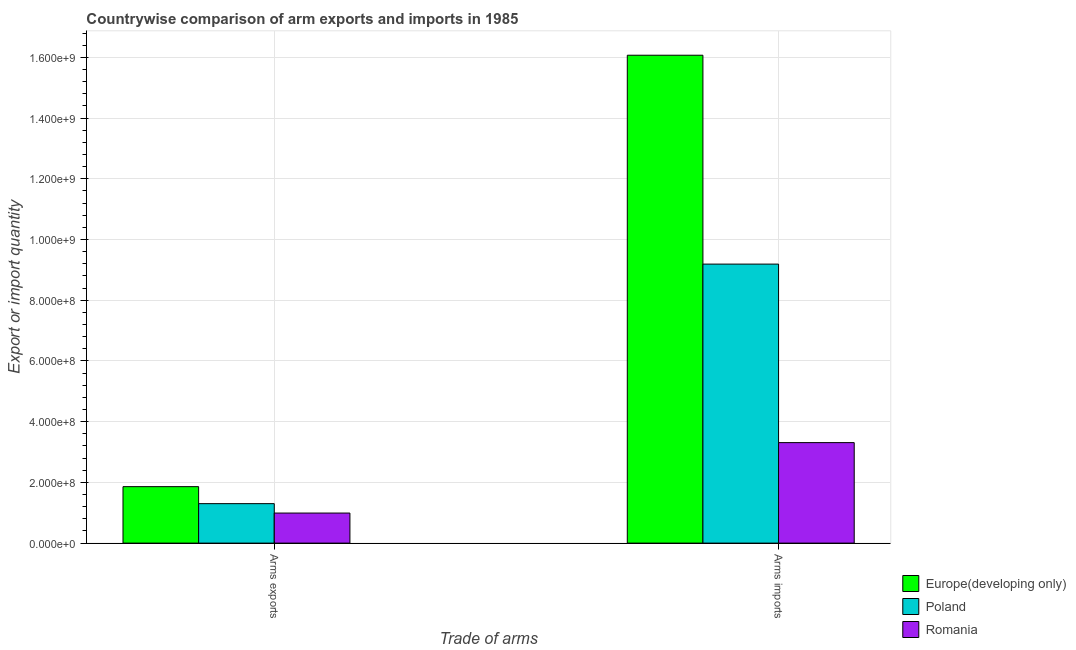How many groups of bars are there?
Ensure brevity in your answer.  2. Are the number of bars on each tick of the X-axis equal?
Give a very brief answer. Yes. How many bars are there on the 2nd tick from the left?
Give a very brief answer. 3. How many bars are there on the 2nd tick from the right?
Your answer should be very brief. 3. What is the label of the 2nd group of bars from the left?
Offer a terse response. Arms imports. What is the arms exports in Europe(developing only)?
Offer a terse response. 1.86e+08. Across all countries, what is the maximum arms exports?
Offer a very short reply. 1.86e+08. Across all countries, what is the minimum arms imports?
Make the answer very short. 3.31e+08. In which country was the arms imports maximum?
Your response must be concise. Europe(developing only). In which country was the arms exports minimum?
Your answer should be very brief. Romania. What is the total arms imports in the graph?
Your response must be concise. 2.86e+09. What is the difference between the arms imports in Poland and that in Romania?
Make the answer very short. 5.88e+08. What is the difference between the arms imports in Europe(developing only) and the arms exports in Romania?
Your answer should be very brief. 1.51e+09. What is the average arms exports per country?
Provide a short and direct response. 1.38e+08. What is the difference between the arms imports and arms exports in Poland?
Ensure brevity in your answer.  7.89e+08. In how many countries, is the arms exports greater than 560000000 ?
Offer a very short reply. 0. What is the ratio of the arms imports in Europe(developing only) to that in Poland?
Make the answer very short. 1.75. Is the arms exports in Poland less than that in Europe(developing only)?
Offer a very short reply. Yes. In how many countries, is the arms exports greater than the average arms exports taken over all countries?
Keep it short and to the point. 1. What does the 1st bar from the left in Arms imports represents?
Provide a succinct answer. Europe(developing only). What does the 3rd bar from the right in Arms imports represents?
Give a very brief answer. Europe(developing only). How many bars are there?
Make the answer very short. 6. Are the values on the major ticks of Y-axis written in scientific E-notation?
Make the answer very short. Yes. Does the graph contain any zero values?
Provide a succinct answer. No. What is the title of the graph?
Your answer should be very brief. Countrywise comparison of arm exports and imports in 1985. Does "Upper middle income" appear as one of the legend labels in the graph?
Make the answer very short. No. What is the label or title of the X-axis?
Provide a succinct answer. Trade of arms. What is the label or title of the Y-axis?
Ensure brevity in your answer.  Export or import quantity. What is the Export or import quantity of Europe(developing only) in Arms exports?
Your answer should be compact. 1.86e+08. What is the Export or import quantity of Poland in Arms exports?
Ensure brevity in your answer.  1.30e+08. What is the Export or import quantity of Romania in Arms exports?
Your answer should be very brief. 9.90e+07. What is the Export or import quantity of Europe(developing only) in Arms imports?
Ensure brevity in your answer.  1.61e+09. What is the Export or import quantity of Poland in Arms imports?
Provide a succinct answer. 9.19e+08. What is the Export or import quantity of Romania in Arms imports?
Make the answer very short. 3.31e+08. Across all Trade of arms, what is the maximum Export or import quantity of Europe(developing only)?
Your answer should be compact. 1.61e+09. Across all Trade of arms, what is the maximum Export or import quantity in Poland?
Your answer should be very brief. 9.19e+08. Across all Trade of arms, what is the maximum Export or import quantity in Romania?
Your response must be concise. 3.31e+08. Across all Trade of arms, what is the minimum Export or import quantity of Europe(developing only)?
Your answer should be compact. 1.86e+08. Across all Trade of arms, what is the minimum Export or import quantity of Poland?
Your response must be concise. 1.30e+08. Across all Trade of arms, what is the minimum Export or import quantity in Romania?
Offer a terse response. 9.90e+07. What is the total Export or import quantity in Europe(developing only) in the graph?
Your answer should be very brief. 1.79e+09. What is the total Export or import quantity of Poland in the graph?
Give a very brief answer. 1.05e+09. What is the total Export or import quantity of Romania in the graph?
Provide a succinct answer. 4.30e+08. What is the difference between the Export or import quantity of Europe(developing only) in Arms exports and that in Arms imports?
Your answer should be very brief. -1.42e+09. What is the difference between the Export or import quantity of Poland in Arms exports and that in Arms imports?
Provide a short and direct response. -7.89e+08. What is the difference between the Export or import quantity in Romania in Arms exports and that in Arms imports?
Keep it short and to the point. -2.32e+08. What is the difference between the Export or import quantity in Europe(developing only) in Arms exports and the Export or import quantity in Poland in Arms imports?
Offer a very short reply. -7.33e+08. What is the difference between the Export or import quantity of Europe(developing only) in Arms exports and the Export or import quantity of Romania in Arms imports?
Provide a short and direct response. -1.45e+08. What is the difference between the Export or import quantity in Poland in Arms exports and the Export or import quantity in Romania in Arms imports?
Offer a very short reply. -2.01e+08. What is the average Export or import quantity in Europe(developing only) per Trade of arms?
Your answer should be compact. 8.96e+08. What is the average Export or import quantity in Poland per Trade of arms?
Give a very brief answer. 5.24e+08. What is the average Export or import quantity of Romania per Trade of arms?
Make the answer very short. 2.15e+08. What is the difference between the Export or import quantity of Europe(developing only) and Export or import quantity of Poland in Arms exports?
Your response must be concise. 5.60e+07. What is the difference between the Export or import quantity in Europe(developing only) and Export or import quantity in Romania in Arms exports?
Your answer should be compact. 8.70e+07. What is the difference between the Export or import quantity in Poland and Export or import quantity in Romania in Arms exports?
Your response must be concise. 3.10e+07. What is the difference between the Export or import quantity in Europe(developing only) and Export or import quantity in Poland in Arms imports?
Give a very brief answer. 6.88e+08. What is the difference between the Export or import quantity in Europe(developing only) and Export or import quantity in Romania in Arms imports?
Your answer should be compact. 1.28e+09. What is the difference between the Export or import quantity of Poland and Export or import quantity of Romania in Arms imports?
Provide a short and direct response. 5.88e+08. What is the ratio of the Export or import quantity of Europe(developing only) in Arms exports to that in Arms imports?
Your response must be concise. 0.12. What is the ratio of the Export or import quantity of Poland in Arms exports to that in Arms imports?
Provide a short and direct response. 0.14. What is the ratio of the Export or import quantity of Romania in Arms exports to that in Arms imports?
Offer a terse response. 0.3. What is the difference between the highest and the second highest Export or import quantity in Europe(developing only)?
Provide a succinct answer. 1.42e+09. What is the difference between the highest and the second highest Export or import quantity of Poland?
Give a very brief answer. 7.89e+08. What is the difference between the highest and the second highest Export or import quantity in Romania?
Ensure brevity in your answer.  2.32e+08. What is the difference between the highest and the lowest Export or import quantity of Europe(developing only)?
Provide a short and direct response. 1.42e+09. What is the difference between the highest and the lowest Export or import quantity in Poland?
Offer a terse response. 7.89e+08. What is the difference between the highest and the lowest Export or import quantity of Romania?
Ensure brevity in your answer.  2.32e+08. 